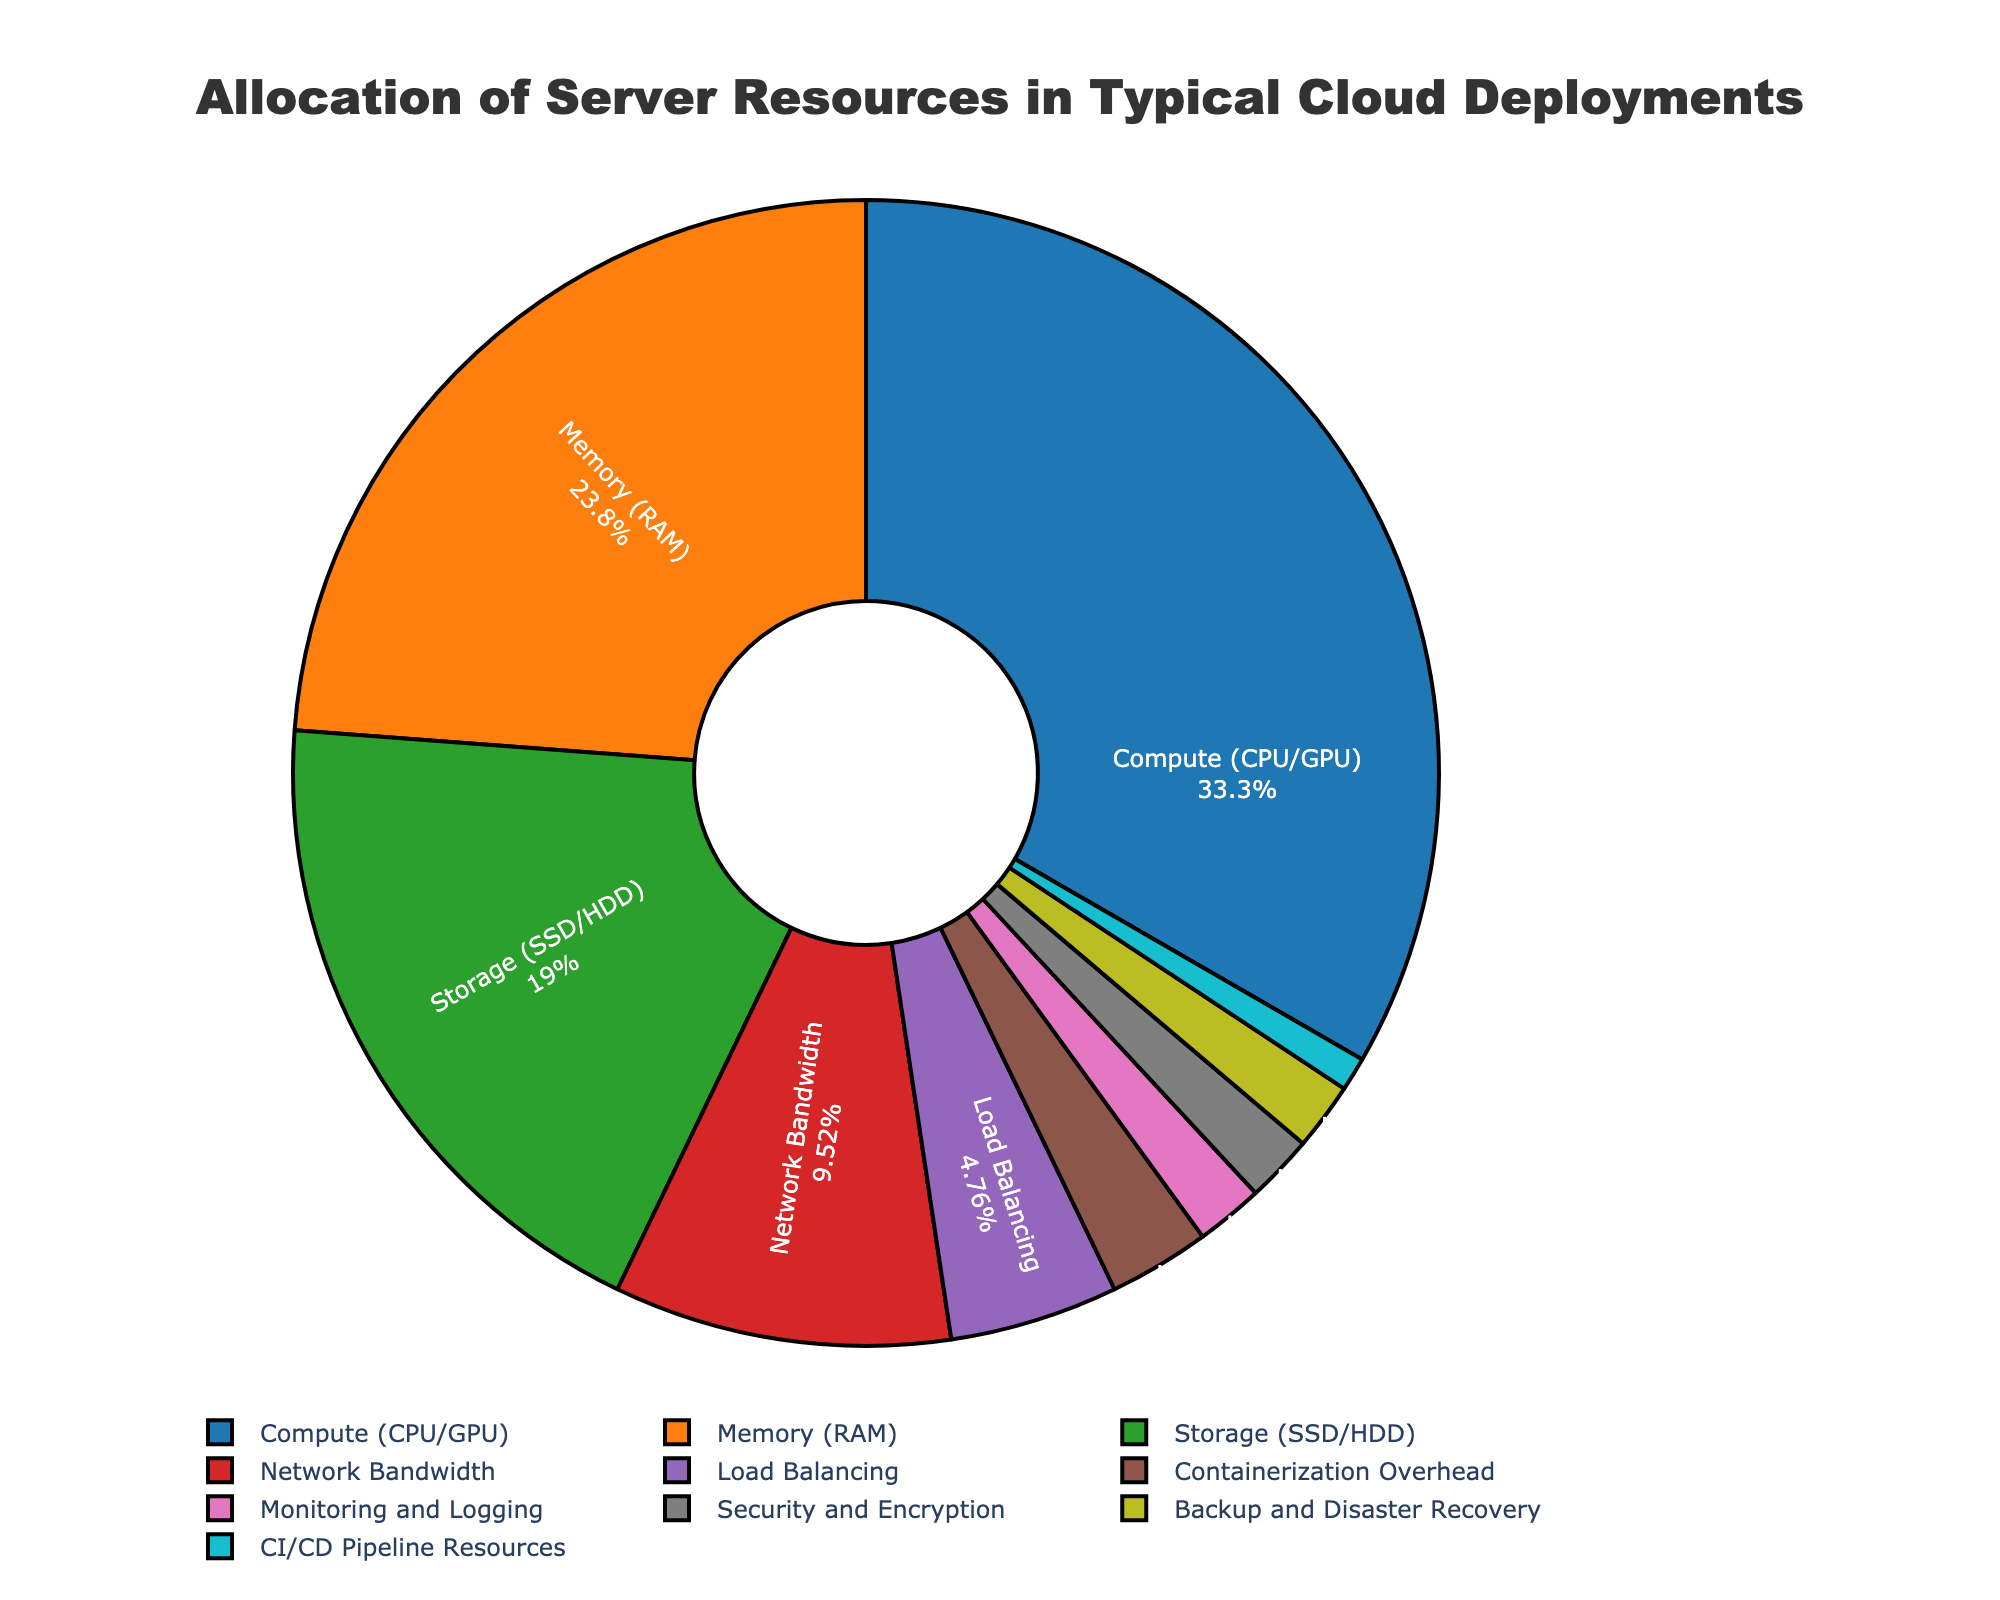What's the largest allocation of server resources? The largest section of the pie chart corresponds to Compute (CPU/GPU). The percentage shown in the chart for this category is 35%.
Answer: Compute (CPU/GPU) What's the total percentage allocated to Memory (RAM) and Storage (SSD/HDD)? Memory (RAM) uses 25% of the resources, and Storage (SSD/HDD) uses 20%. Summing these up: 25% + 20% = 45%.
Answer: 45% Which resource has the smallest allocation and what is its percentage? The smallest section of the pie chart corresponds to CI/CD Pipeline Resources, with a percentage of 1%.
Answer: CI/CD Pipeline Resources, 1% Are the resources allocated to Security and Encryption equal to Containerization Overhead? The pie chart shows Security and Encryption at 2% and Containerization Overhead at 3%, so they are not equal.
Answer: No What's the combined allocation for resources related to monitoring and security? Summing the Monitoring and Logging (2%) and Security and Encryption (2%) allocations: 2% + 2% = 4%.
Answer: 4% Which resource categories have allocations under 5%? The categories with allocations under 5% are Load Balancing (5%), Containerization Overhead (3%), Monitoring and Logging (2%), Security and Encryption (2%), Backup and Disaster Recovery (2%), and CI/CD Pipeline Resources (1%).
Answer: Load Balancing, Containerization Overhead, Monitoring and Logging, Security and Encryption, Backup and Disaster Recovery, CI/CD Pipeline Resources What is the difference between the percentages allocated to Network Bandwidth and Load Balancing? The chart shows Network Bandwidth at 10% and Load Balancing at 5%. The difference is 10% - 5% = 5%.
Answer: 5% Which resource is twice as large in allocation as Network Bandwidth? Network Bandwidth is allocated 10%. Compute (CPU/GPU) is allocated 35%, which is not twice the size. No other category matches twice the size of 10%. Hence, no resource is exactly twice as large.
Answer: None How does the allocation for Backup and Disaster Recovery compare to that for Monitoring and Logging? Both Backup and Disaster Recovery and Monitoring and Logging are allocated 2%. So, they have the same allocation.
Answer: Same What's the combined percentage for non-Compute categories? The total allocation adds up to 100%. Subtracting the allocation for Compute (CPU/GPU), which is 35%: 100% - 35% = 65%.
Answer: 65% 